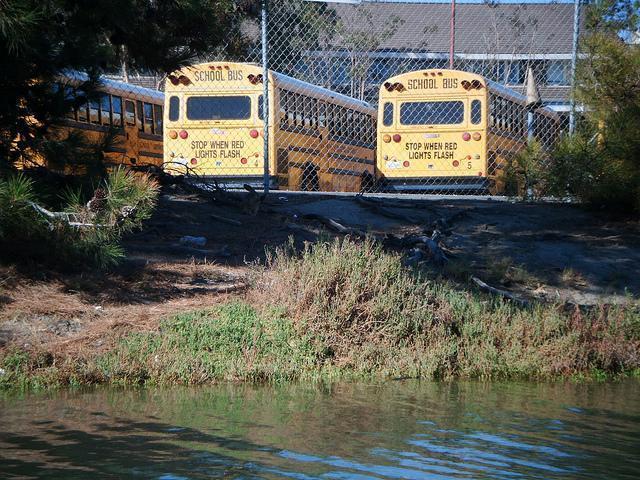How many buses can you see?
Give a very brief answer. 3. How many people are represented by the feet shown in the photo?
Give a very brief answer. 0. 